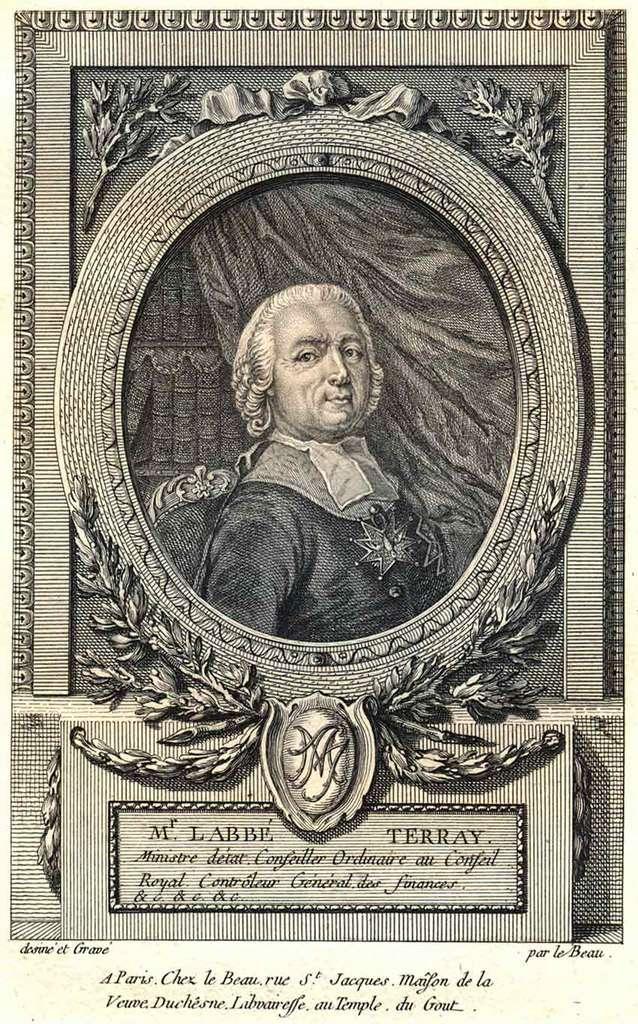Who is this a portrait of?
Provide a succinct answer. Labbe terray. 